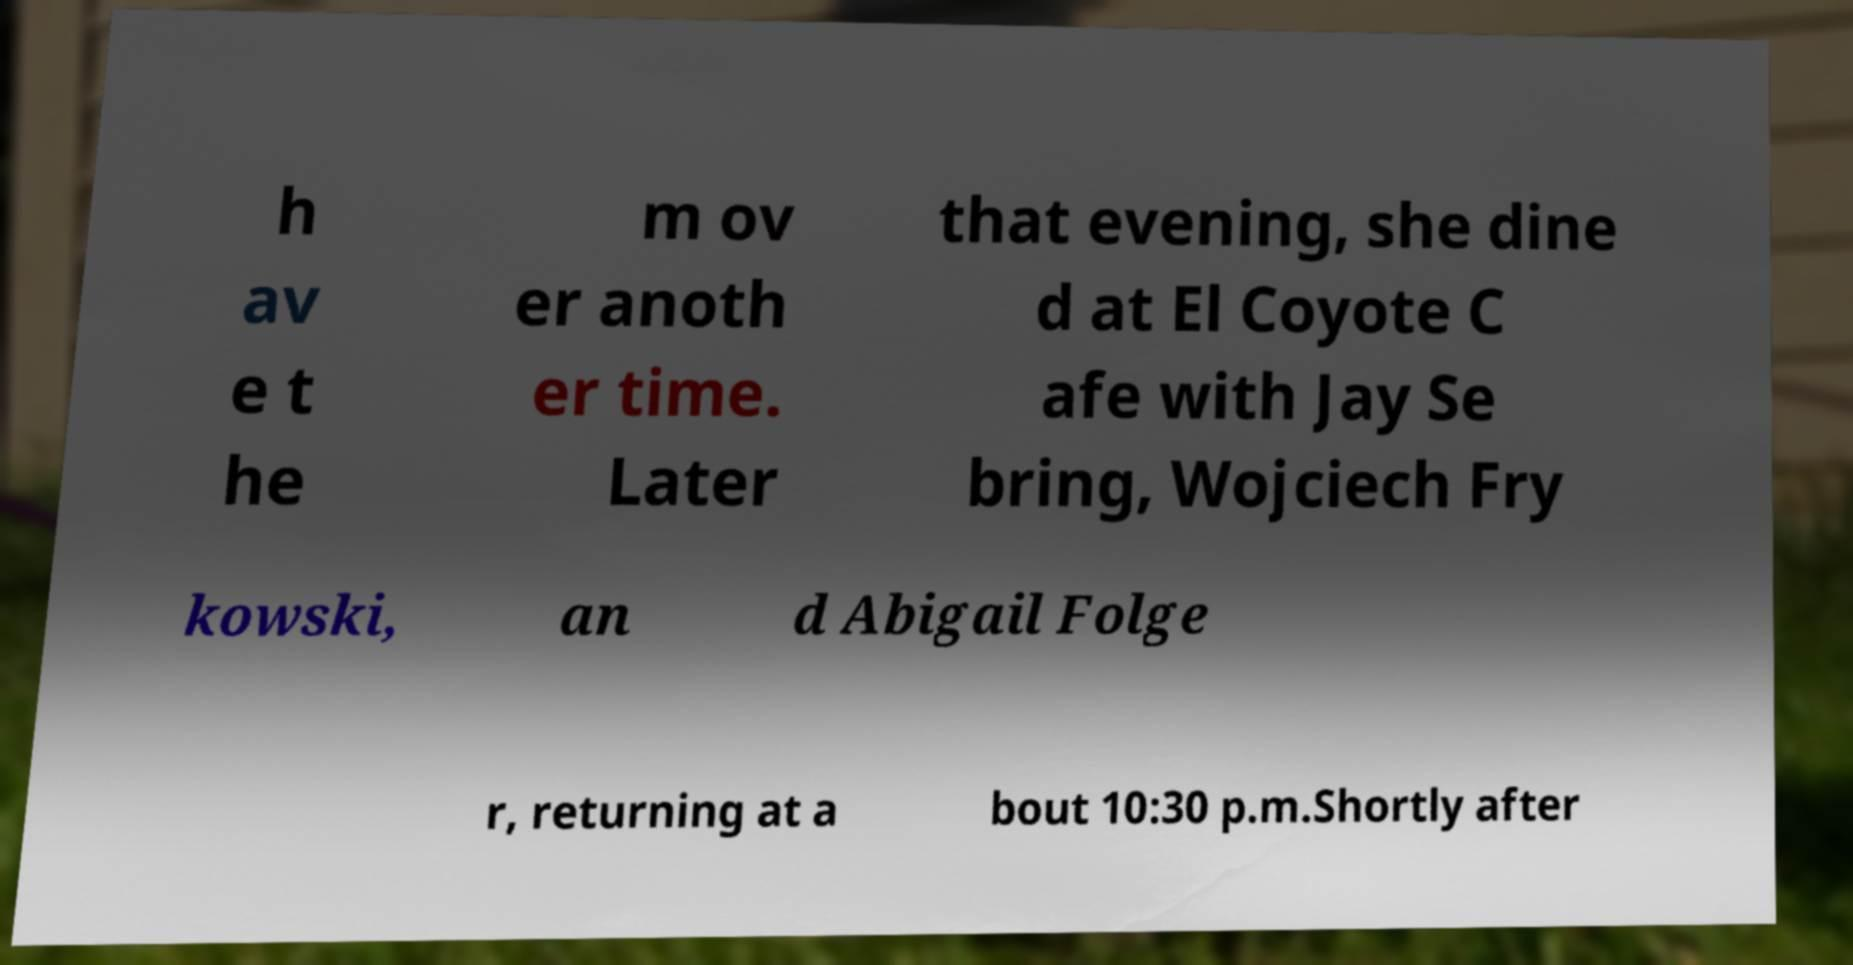Can you read and provide the text displayed in the image?This photo seems to have some interesting text. Can you extract and type it out for me? h av e t he m ov er anoth er time. Later that evening, she dine d at El Coyote C afe with Jay Se bring, Wojciech Fry kowski, an d Abigail Folge r, returning at a bout 10:30 p.m.Shortly after 